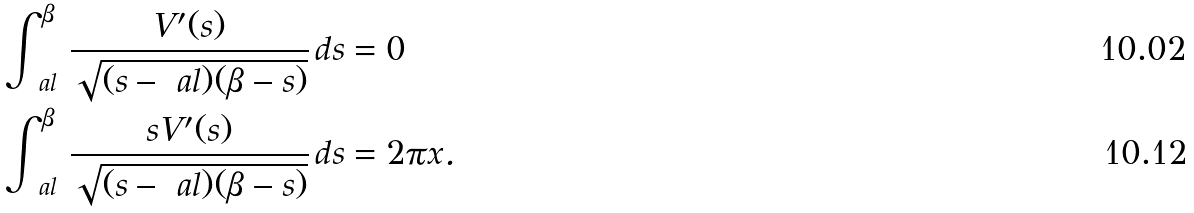Convert formula to latex. <formula><loc_0><loc_0><loc_500><loc_500>\int ^ { \beta } _ { \ a l } \, \frac { V ^ { \prime } ( s ) } { \sqrt { ( s - \ a l ) ( \beta - s ) } } \, d s & = 0 \\ \int ^ { \beta } _ { \ a l } \, \frac { s V ^ { \prime } ( s ) } { \sqrt { ( s - \ a l ) ( \beta - s ) } } \, d s & = 2 \pi x .</formula> 